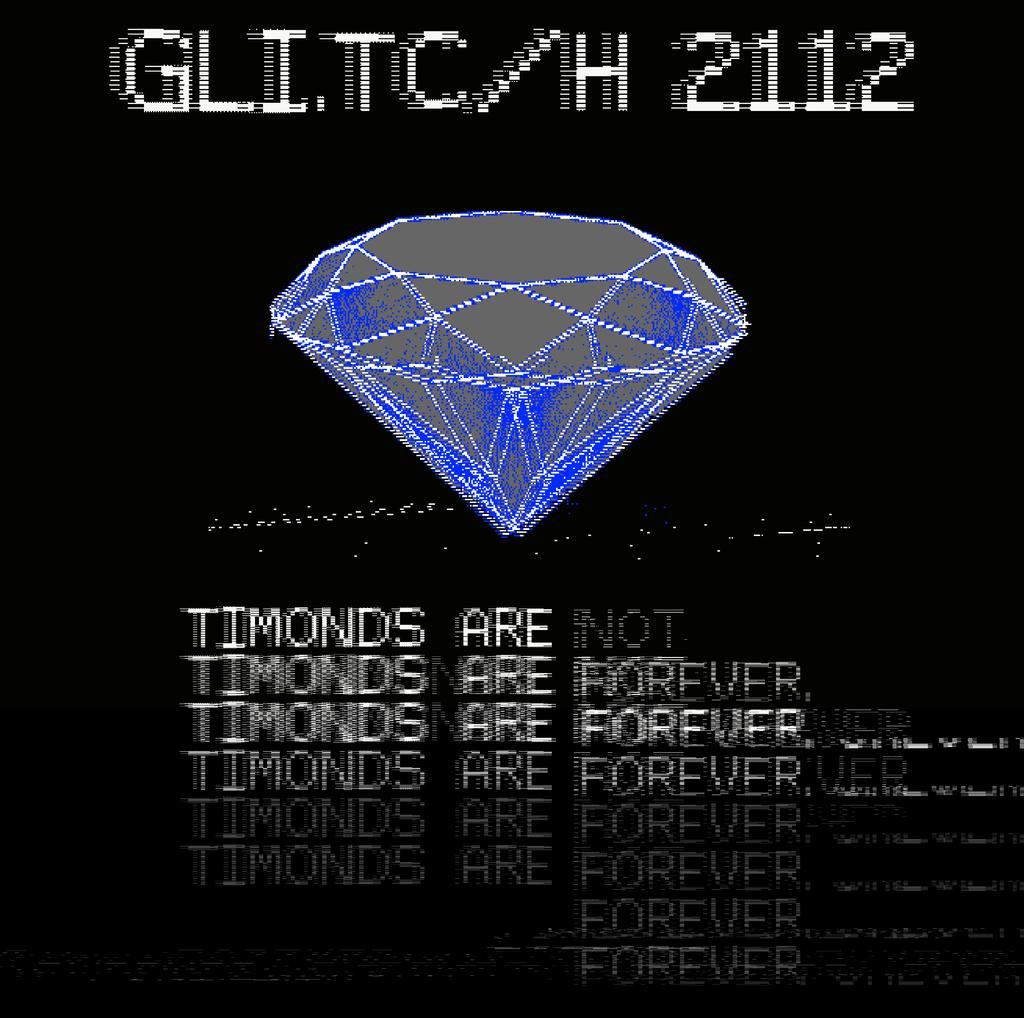<image>
Present a compact description of the photo's key features. A weird computer generated screen that says Timonds are not forever. 